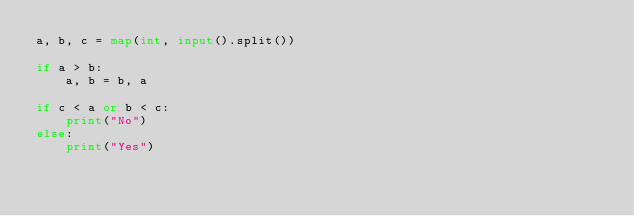Convert code to text. <code><loc_0><loc_0><loc_500><loc_500><_Python_>a, b, c = map(int, input().split())

if a > b:
    a, b = b, a

if c < a or b < c:
    print("No")
else:
    print("Yes")
</code> 